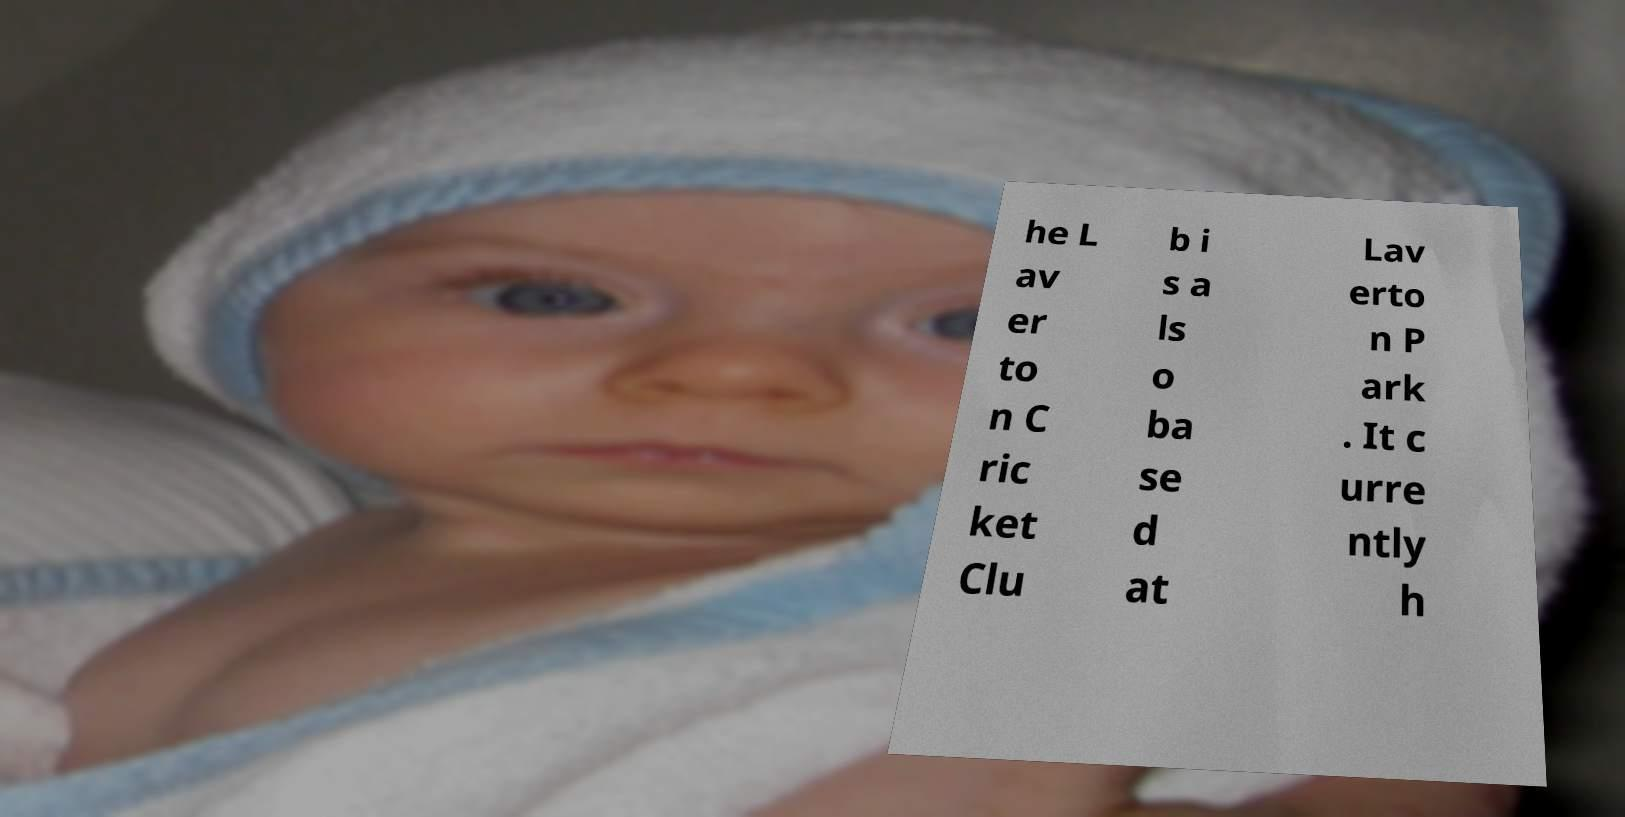Can you read and provide the text displayed in the image?This photo seems to have some interesting text. Can you extract and type it out for me? he L av er to n C ric ket Clu b i s a ls o ba se d at Lav erto n P ark . It c urre ntly h 